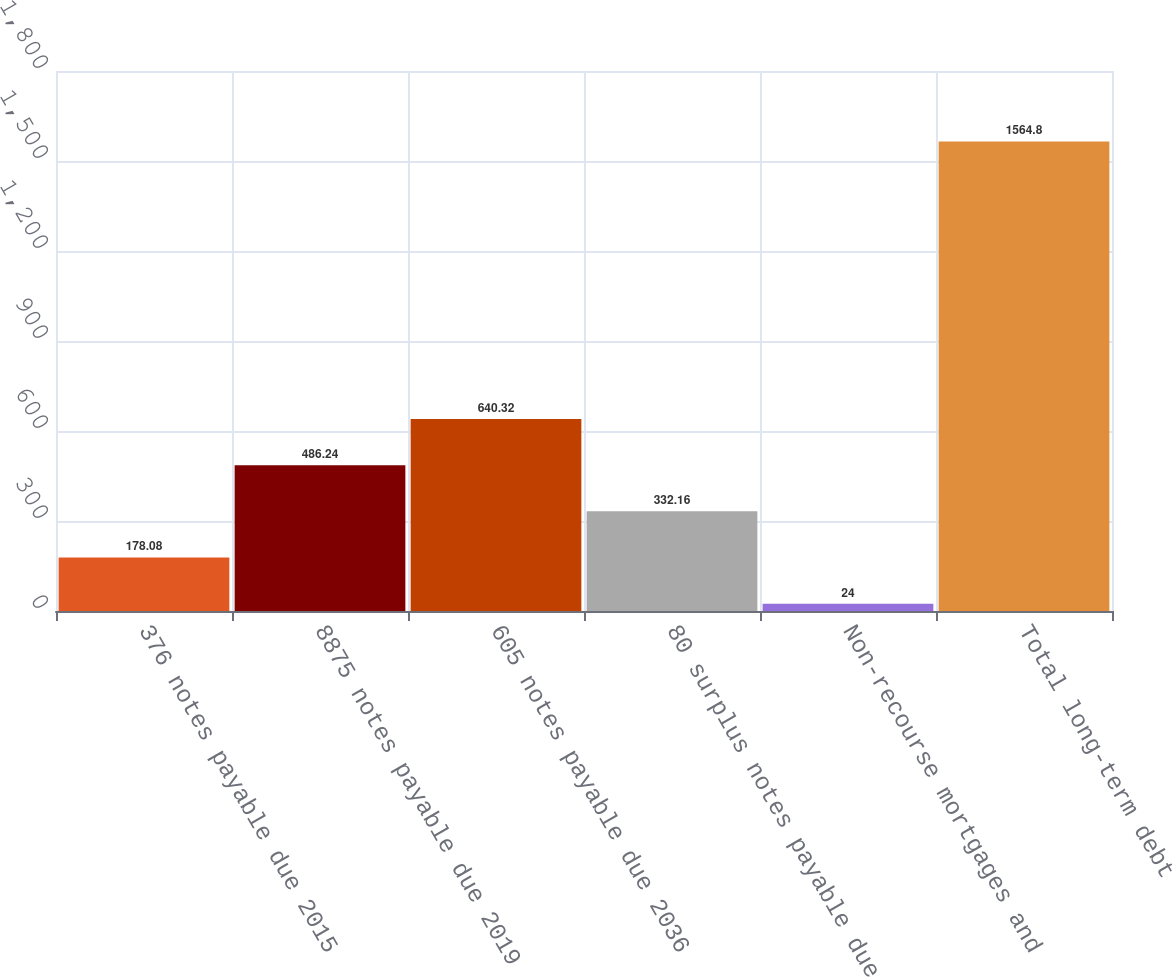Convert chart to OTSL. <chart><loc_0><loc_0><loc_500><loc_500><bar_chart><fcel>376 notes payable due 2015<fcel>8875 notes payable due 2019<fcel>605 notes payable due 2036<fcel>80 surplus notes payable due<fcel>Non-recourse mortgages and<fcel>Total long-term debt<nl><fcel>178.08<fcel>486.24<fcel>640.32<fcel>332.16<fcel>24<fcel>1564.8<nl></chart> 